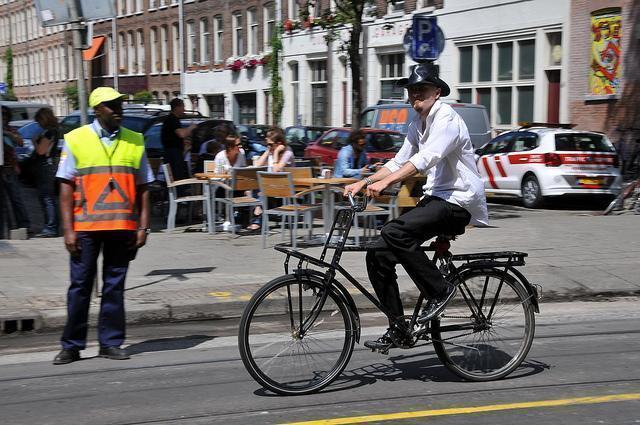Why is the man on the road wearing a whistle?
Answer the question by selecting the correct answer among the 4 following choices and explain your choice with a short sentence. The answer should be formatted with the following format: `Answer: choice
Rationale: rationale.`
Options: Crossing guard, no sidewalk, street performer, jaywalking. Answer: crossing guard.
Rationale: The crossing guard uses the whistle to direct traffic. 